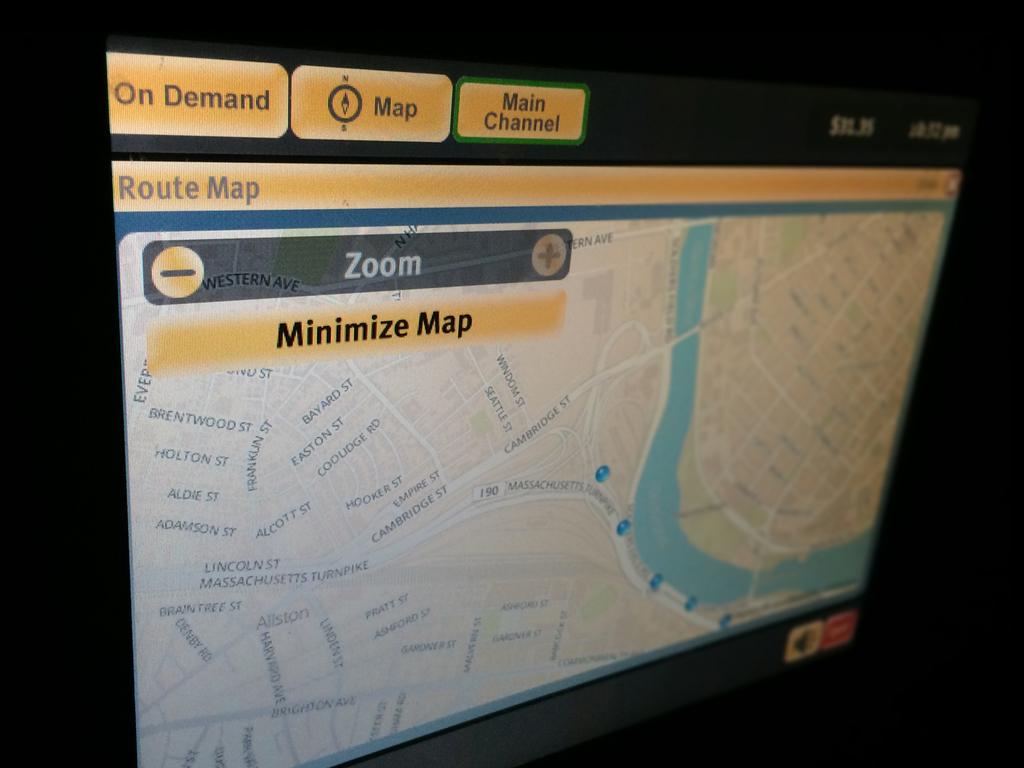What does the middle button do?
Provide a short and direct response. Map. What does the yellow button on the top left say?
Your answer should be very brief. On demand. 